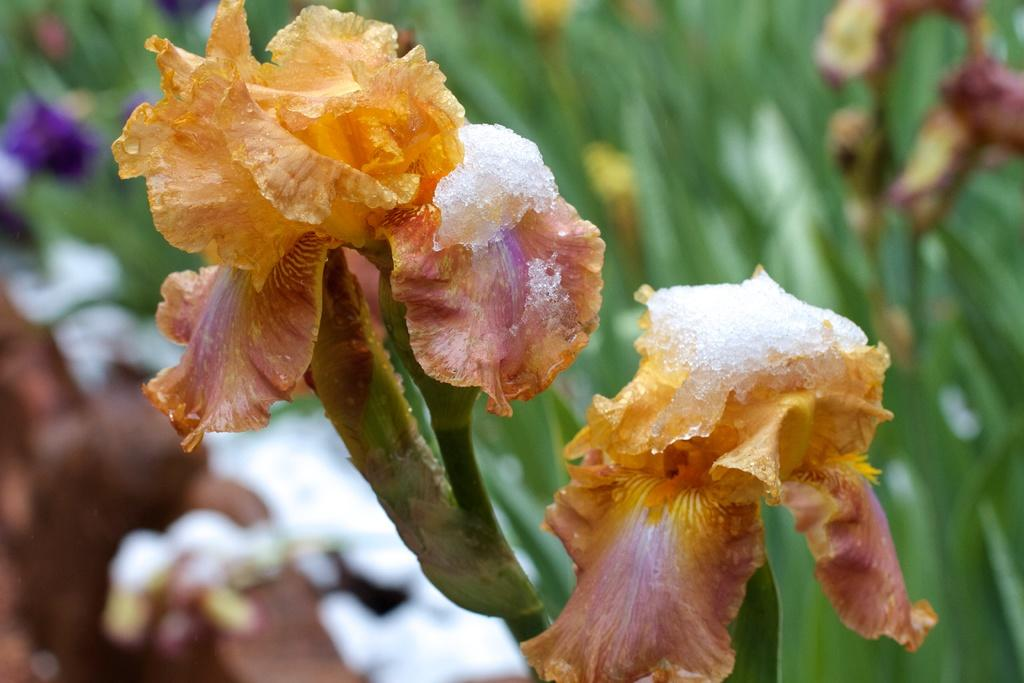What type of plant life can be seen in the image? There are flowers and leaves in the image. Can you describe the flowers in the image? Unfortunately, the facts provided do not give specific details about the flowers. What is the context of the image? The facts provided do not give any information about the context or setting of the image. How does the cave in the image affect the growth of the flowers? There is no cave present in the image; it only features flowers and leaves. What type of oil is used to maintain the flowers in the image? There is no mention of oil being used to maintain the flowers in the image. 